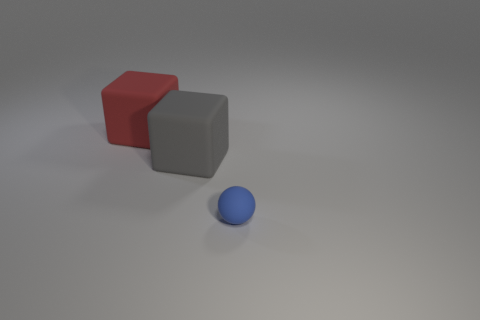How many big yellow things have the same shape as the gray thing?
Make the answer very short. 0. How many things are either cubes right of the red cube or rubber objects that are on the right side of the gray thing?
Ensure brevity in your answer.  2. Are there any spheres that are left of the big rubber block on the left side of the big gray rubber object?
Offer a terse response. No. What number of things are either large blocks that are to the left of the gray matte cube or spheres?
Make the answer very short. 2. There is a rubber object that is on the right side of the big gray cube; how big is it?
Give a very brief answer. Small. There is a small object that is the same material as the large red thing; what shape is it?
Offer a terse response. Sphere. Does the rubber thing that is behind the gray block have the same shape as the big gray matte object?
Ensure brevity in your answer.  Yes. What is the material of the other thing that is the same shape as the big gray object?
Provide a succinct answer. Rubber. Does the red rubber thing have the same shape as the big thing in front of the red cube?
Keep it short and to the point. Yes. What color is the matte thing that is both behind the blue rubber sphere and to the right of the big red cube?
Make the answer very short. Gray. 